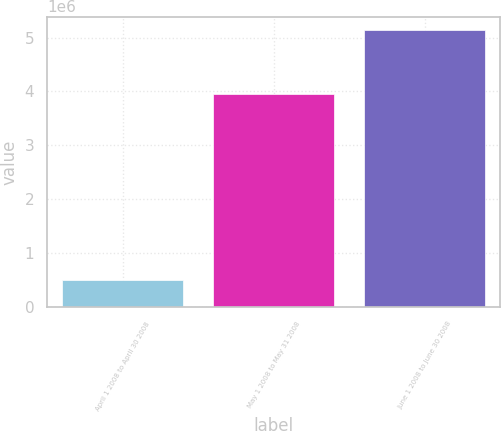Convert chart. <chart><loc_0><loc_0><loc_500><loc_500><bar_chart><fcel>April 1 2008 to April 30 2008<fcel>May 1 2008 to May 31 2008<fcel>June 1 2008 to June 30 2008<nl><fcel>501500<fcel>3.9565e+06<fcel>5.1308e+06<nl></chart> 